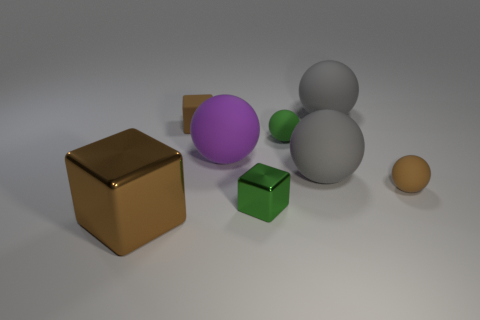The rubber thing that is the same color as the tiny shiny block is what shape?
Keep it short and to the point. Sphere. How big is the green cube that is on the right side of the small brown cube?
Offer a terse response. Small. There is a brown shiny object that is the same size as the purple object; what is its shape?
Provide a succinct answer. Cube. Is the gray thing in front of the big purple thing made of the same material as the small brown thing that is to the right of the small green cube?
Your response must be concise. Yes. There is a tiny object on the left side of the matte sphere that is left of the small green shiny cube; what is it made of?
Offer a very short reply. Rubber. How big is the gray sphere in front of the gray sphere behind the brown block that is to the right of the large shiny thing?
Your answer should be very brief. Large. Does the rubber cube have the same size as the purple ball?
Your answer should be very brief. No. Is the shape of the shiny thing behind the brown metallic cube the same as the brown rubber thing that is behind the green ball?
Ensure brevity in your answer.  Yes. There is a tiny rubber ball that is in front of the large purple matte ball; is there a big thing that is in front of it?
Give a very brief answer. Yes. Are any blue things visible?
Your response must be concise. No. 